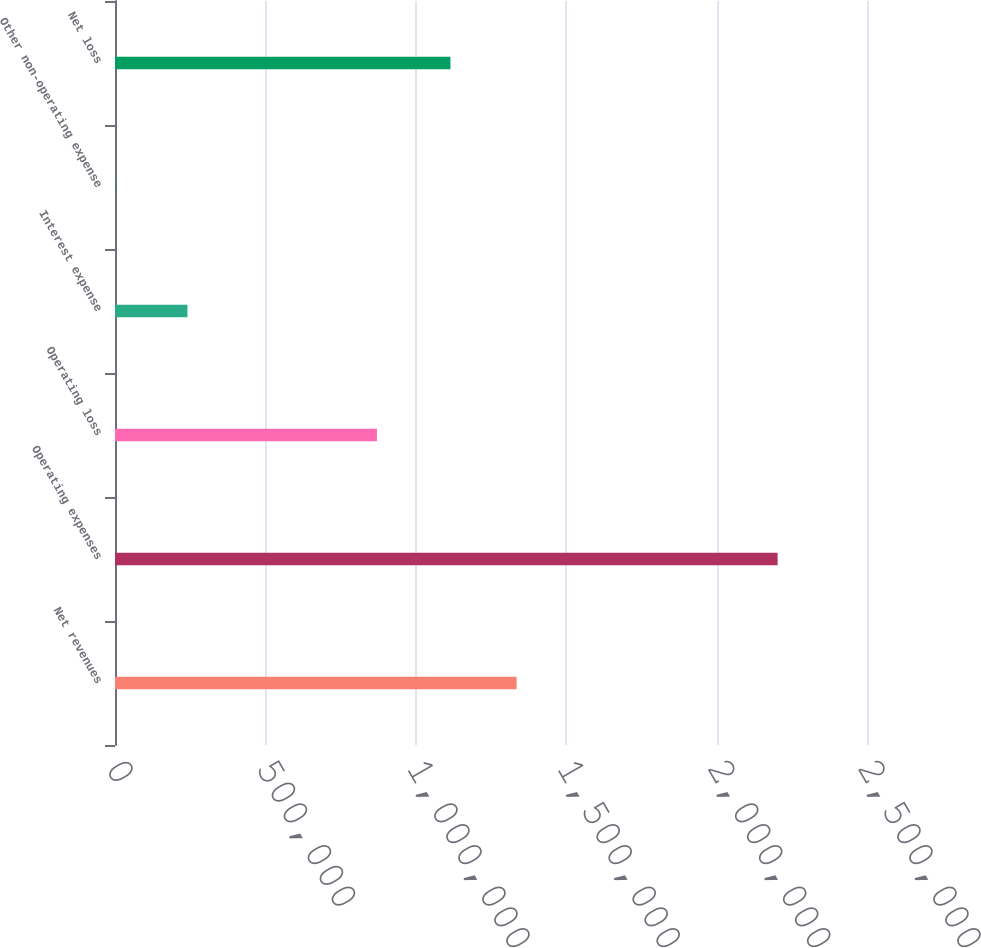<chart> <loc_0><loc_0><loc_500><loc_500><bar_chart><fcel>Net revenues<fcel>Operating expenses<fcel>Operating loss<fcel>Interest expense<fcel>Other non-operating expense<fcel>Net loss<nl><fcel>1.33512e+06<fcel>2.20291e+06<fcel>870845<fcel>240731<fcel>3614<fcel>1.11519e+06<nl></chart> 